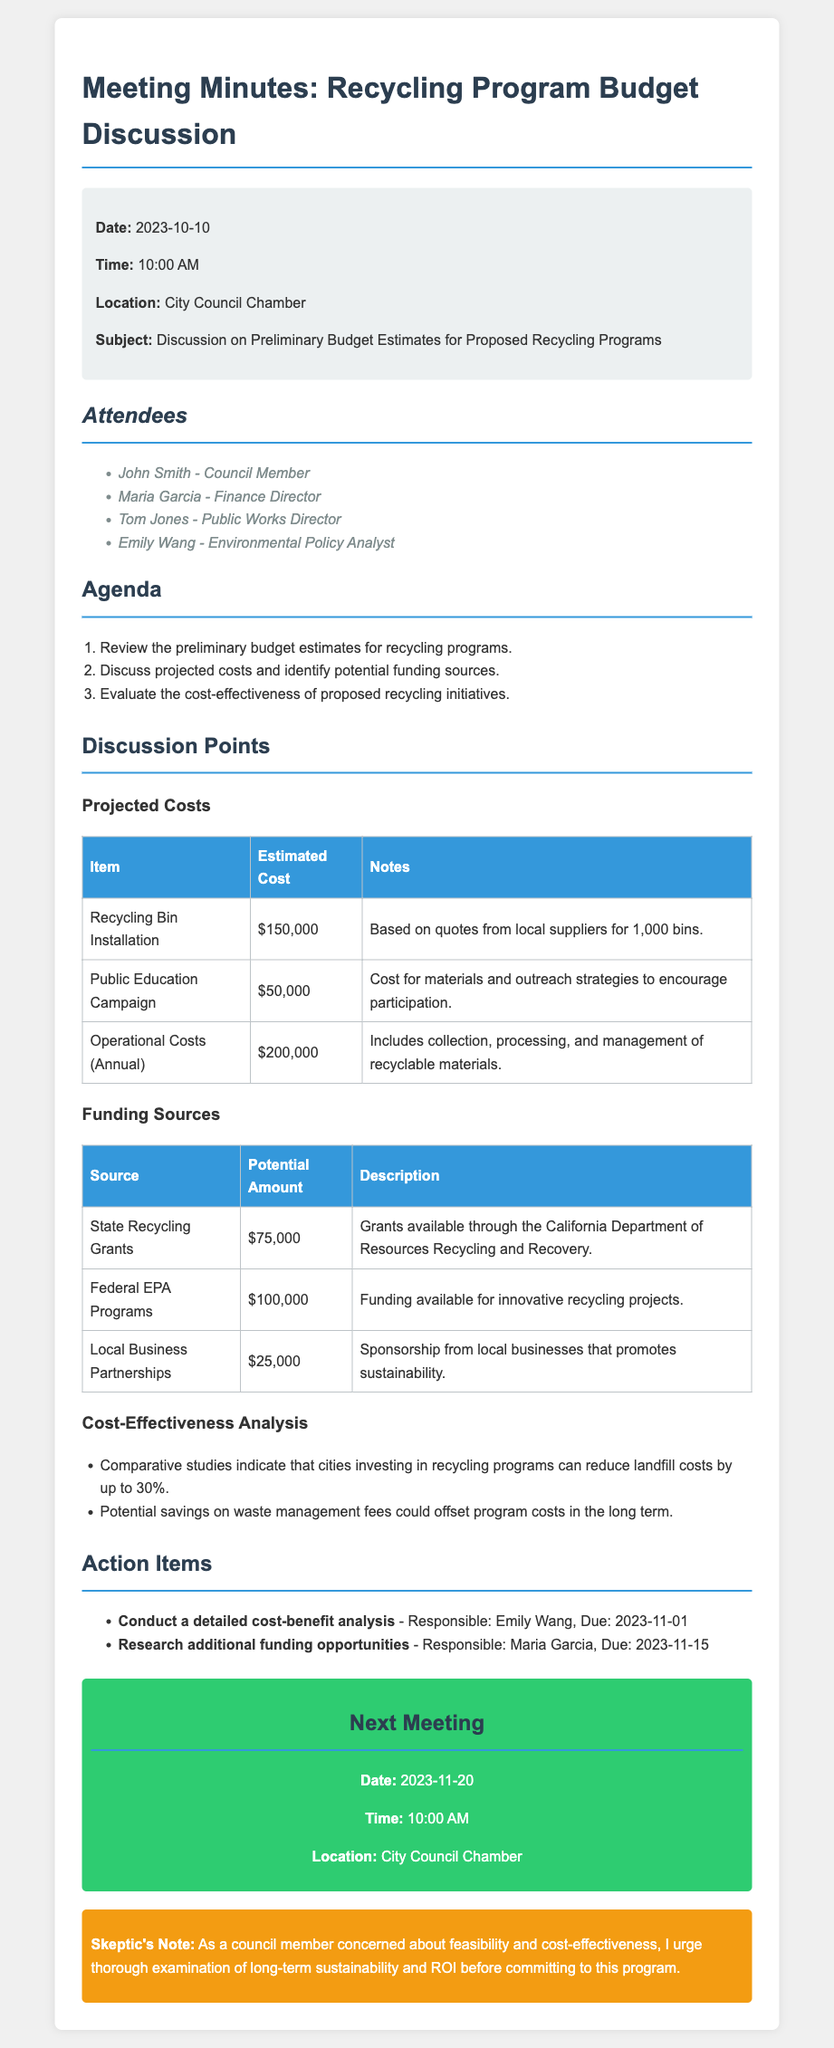What is the total estimated cost for recycling bin installation? The total estimated cost for recycling bin installation is stated in the document, which is $150,000.
Answer: $150,000 What is the amount of funding from Federal EPA Programs? The amount of funding from Federal EPA Programs is included in the funding sources table, which is $100,000.
Answer: $100,000 Who is responsible for conducting the detailed cost-benefit analysis? The document specifies the action item and responsible person for the detailed cost-benefit analysis, which is Emily Wang.
Answer: Emily Wang What date is the next meeting scheduled? The date for the next meeting is mentioned in the document as November 20, 2023.
Answer: November 20, 2023 What are the estimated operational costs per year? The estimated operational costs per year are listed in the discussion section, which is $200,000.
Answer: $200,000 What is the total amount of funding from local business partnerships? The local business partnerships funding amount is stated in the funding sources table, which is $25,000.
Answer: $25,000 How much does the public education campaign cost? The cost of the public education campaign is mentioned in the document, which is $50,000.
Answer: $50,000 What percentage of landfill cost reduction is indicated by comparative studies? The comparative studies indicate that cities can reduce landfill costs by up to 30%.
Answer: 30% 